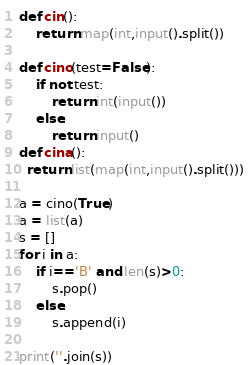Convert code to text. <code><loc_0><loc_0><loc_500><loc_500><_Python_>def cin():
	return map(int,input().split())

def cino(test=False):
    if not test:
        return int(input())
    else:
        return input()
def cina():
  return list(map(int,input().split()))

a = cino(True)
a = list(a)
s = []
for i in a:
    if i=='B' and len(s)>0:
        s.pop()
    else:
        s.append(i)

print(''.join(s))

</code> 